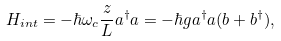<formula> <loc_0><loc_0><loc_500><loc_500>H _ { i n t } = - \hbar { \omega } _ { c } \frac { z } { L } a ^ { \dagger } a = - \hbar { g } a ^ { \dagger } a ( b + b ^ { \dagger } ) ,</formula> 